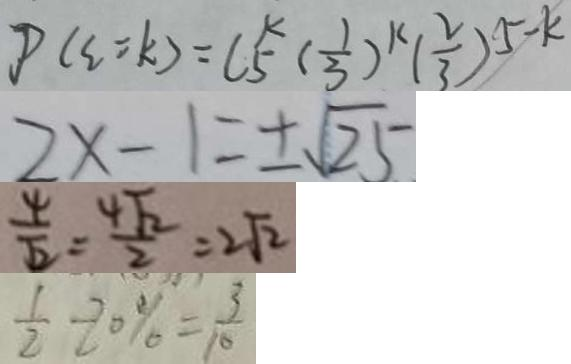<formula> <loc_0><loc_0><loc_500><loc_500>P ( \xi = k ) = C _ { 5 } ^ { k } ( \frac { 1 } { 3 } ) ^ { k } ( \frac { 2 } { 3 } ) ^ { 5 - k } 
 2 x - 1 = \pm \sqrt { 2 5 } 
 \frac { 4 } { \sqrt { 2 } } = \frac { 4 \sqrt { 2 } } { 2 } = 2 \sqrt { 2 } 
 \frac { 1 } { 2 } - 2 0 \% = \frac { 3 } { 1 0 }</formula> 